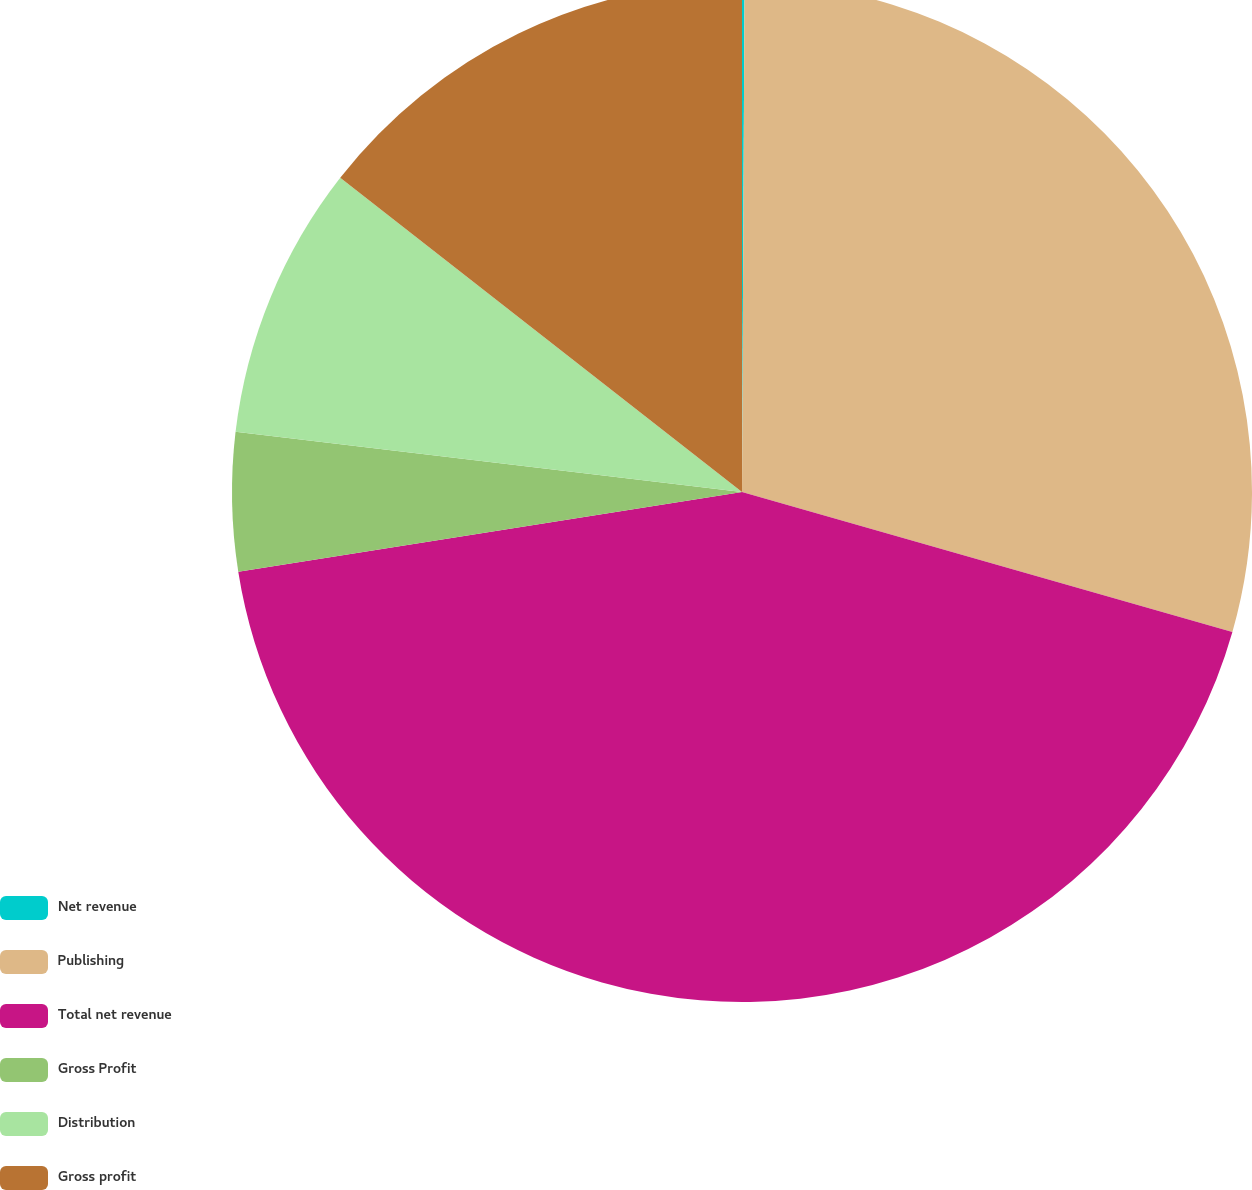Convert chart to OTSL. <chart><loc_0><loc_0><loc_500><loc_500><pie_chart><fcel>Net revenue<fcel>Publishing<fcel>Total net revenue<fcel>Gross Profit<fcel>Distribution<fcel>Gross profit<nl><fcel>0.08%<fcel>29.35%<fcel>43.08%<fcel>4.38%<fcel>8.68%<fcel>14.44%<nl></chart> 